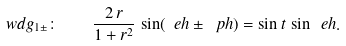Convert formula to latex. <formula><loc_0><loc_0><loc_500><loc_500>\ w d g _ { 1 \pm } \colon \quad \frac { 2 \, r } { 1 + r ^ { 2 } } \, \sin ( \ e h \pm \ p h ) = \sin t \, \sin \ e h .</formula> 